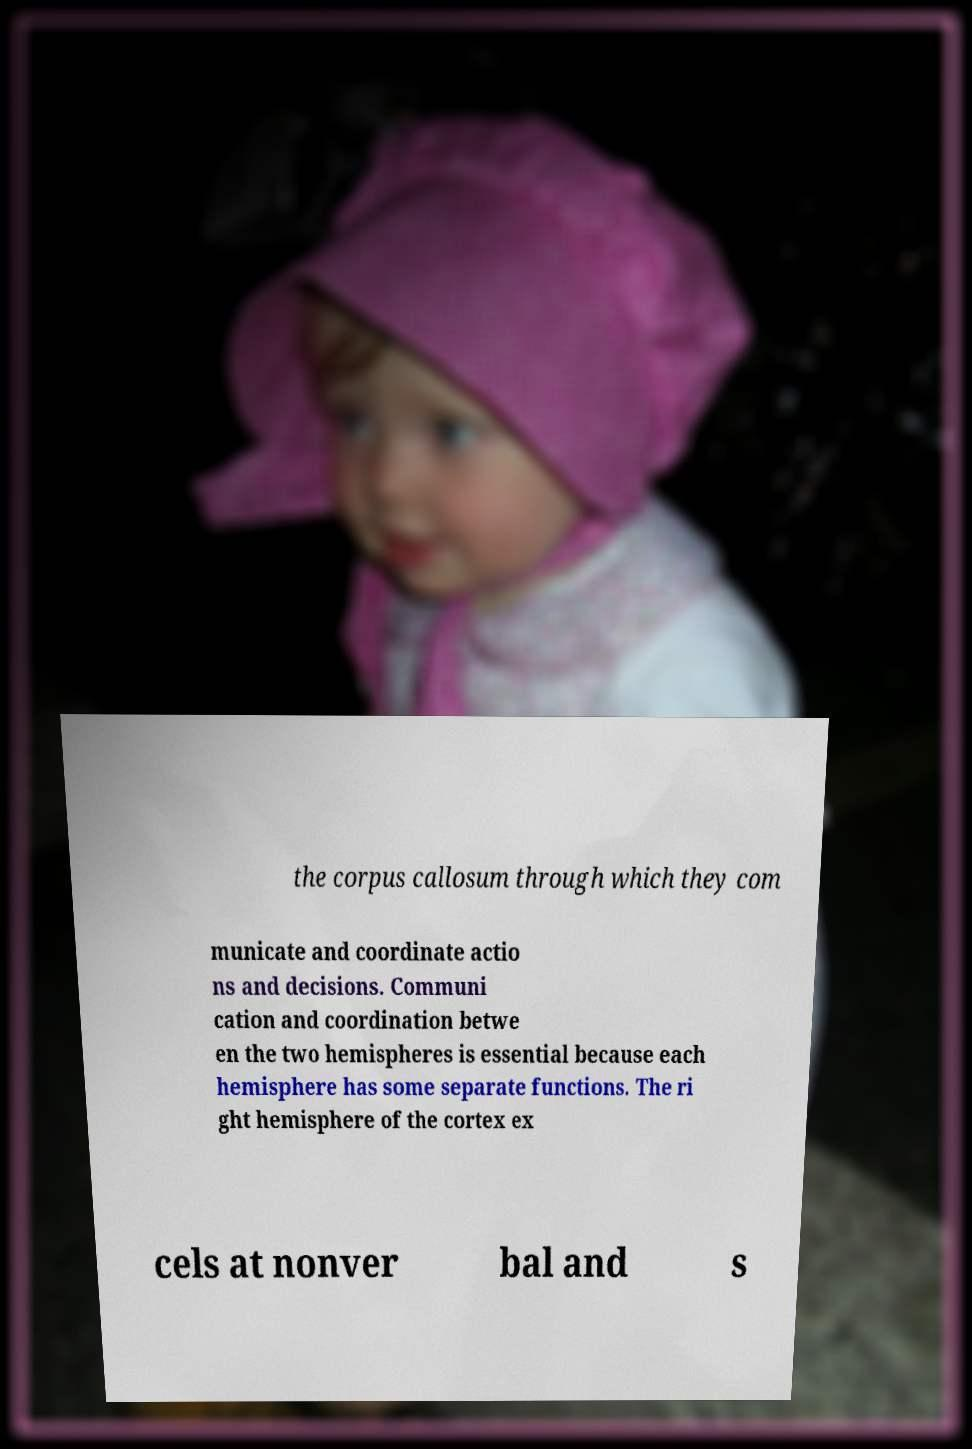Could you extract and type out the text from this image? the corpus callosum through which they com municate and coordinate actio ns and decisions. Communi cation and coordination betwe en the two hemispheres is essential because each hemisphere has some separate functions. The ri ght hemisphere of the cortex ex cels at nonver bal and s 